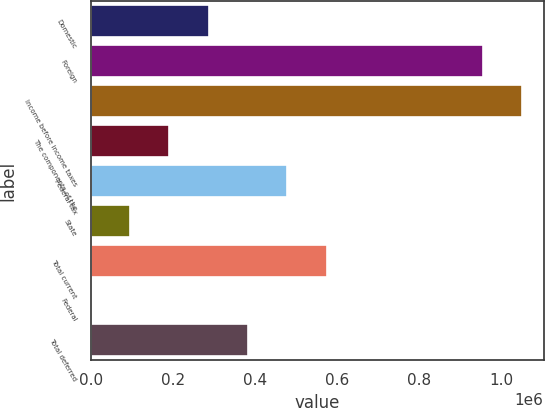Convert chart. <chart><loc_0><loc_0><loc_500><loc_500><bar_chart><fcel>Domestic<fcel>Foreign<fcel>Income before income taxes<fcel>The components of the<fcel>Federal tax<fcel>State<fcel>Total current<fcel>Federal<fcel>Total deferred<nl><fcel>287304<fcel>954279<fcel>1.04994e+06<fcel>191644<fcel>478623<fcel>95984.6<fcel>574283<fcel>325<fcel>382963<nl></chart> 